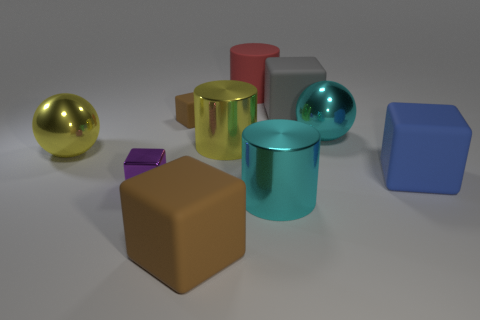Are there fewer big cyan spheres that are in front of the tiny purple metallic block than small gray matte cylinders?
Your answer should be compact. No. What number of shiny objects are red things or large blue things?
Your response must be concise. 0. Are there any other things of the same color as the tiny matte object?
Make the answer very short. Yes. There is a large rubber thing to the left of the large red matte cylinder; is its shape the same as the brown object that is behind the purple object?
Provide a succinct answer. Yes. How many things are either small matte cubes or metallic cylinders behind the small purple metallic cube?
Keep it short and to the point. 2. What number of other things are there of the same size as the yellow ball?
Provide a succinct answer. 7. Is the material of the cyan object that is on the right side of the cyan metal cylinder the same as the yellow cylinder right of the large brown thing?
Give a very brief answer. Yes. There is a matte cylinder; what number of cyan things are left of it?
Offer a terse response. 0. What number of green objects are either large spheres or metallic objects?
Your answer should be compact. 0. There is a blue object that is the same size as the gray rubber block; what material is it?
Provide a succinct answer. Rubber. 